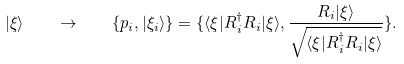<formula> <loc_0><loc_0><loc_500><loc_500>| \xi \rangle \quad \rightarrow \quad \{ p _ { i } , | \xi _ { i } \rangle \} = \{ \langle \xi | R _ { i } ^ { \dagger } R _ { i } | \xi \rangle , \frac { R _ { i } | \xi \rangle } { \sqrt { \langle \xi | R _ { i } ^ { \dagger } R _ { i } | \xi \rangle } } \} .</formula> 